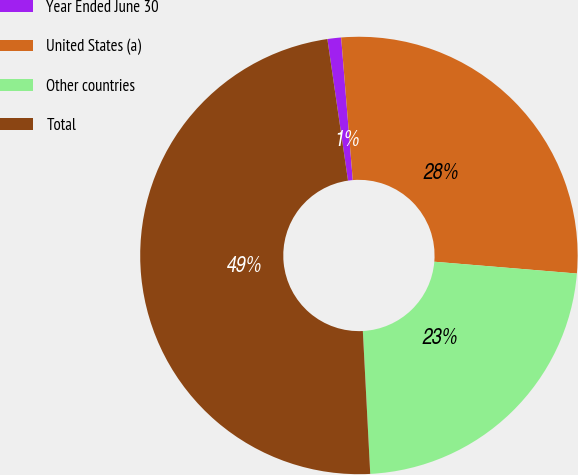<chart> <loc_0><loc_0><loc_500><loc_500><pie_chart><fcel>Year Ended June 30<fcel>United States (a)<fcel>Other countries<fcel>Total<nl><fcel>1.01%<fcel>27.61%<fcel>22.86%<fcel>48.52%<nl></chart> 